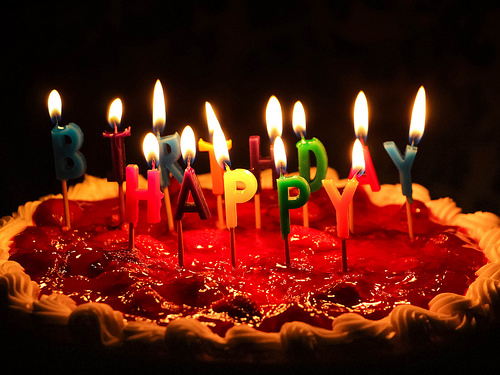<image>
Can you confirm if the darkness is above the flame? Yes. The darkness is positioned above the flame in the vertical space, higher up in the scene. 